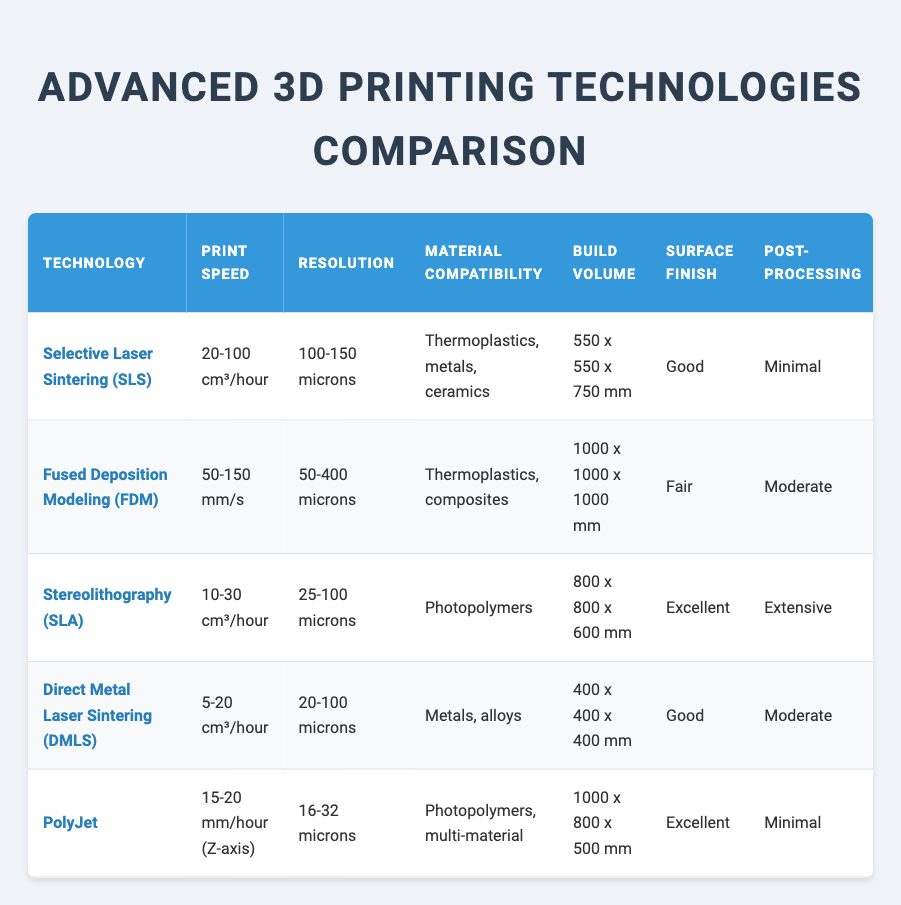What is the print speed range for Stereolithography (SLA)? The print speed for Stereolithography (SLA) is listed as 10-30 cm³/hour in the table.
Answer: 10-30 cm³/hour Which technology has the highest energy efficiency? The highest energy efficiency is indicated for Fused Deposition Modeling (FDM), which is labeled as "High."
Answer: Fused Deposition Modeling (FDM) What is the build volume for PolyJet technology? The build volume for PolyJet technology is specified as 1000 x 800 x 500 mm in the table.
Answer: 1000 x 800 x 500 mm Does Direct Metal Laser Sintering (DMLS) require extensive post-processing? No, Direct Metal Laser Sintering (DMLS) requires moderate post-processing, not extensive, as stated in the table.
Answer: No Which 3D printing technology has the best surface finish? Both Stereolithography (SLA) and PolyJet have an excellent surface finish according to the table. Therefore, they have the best surface finishes among the listed technologies.
Answer: Stereolithography (SLA) and PolyJet If we consider the cost per part, which technology is the least expensive? Fused Deposition Modeling (FDM) is indicated as the least expensive technology with a cost per part of "$," making it the most economical option in the table.
Answer: Fused Deposition Modeling (FDM) What is the difference in print speed between Selective Laser Sintering (SLS) and Fused Deposition Modeling (FDM)? The print speed for SLS is 20-100 cm³/hour and for FDM it is 50-150 mm/s. First, converting FDM's speed to the same units as SLS (1 cm³ is approximately 1000 mm³), means that FDM can range from about 30-450 cm³/hour. Therefore, the difference in maximum print speed is 450 - 100 = 350 cm³/hour, and the minimum is 30 - 20 = 10 cm³/hour.
Answer: Maximum difference: 350 cm³/hour; Minimum difference: 10 cm³/hour Which technology can print the largest build volume? Fused Deposition Modeling (FDM) can print the largest build volume of 1000 x 1000 x 1000 mm, according to the table.
Answer: Fused Deposition Modeling (FDM) Is PolyJet compatible with metals? No, PolyJet is compatible with photopolymers and multi-materials, but not metals as stated in the table.
Answer: No What is the average resolution for all listed technologies? The resolutions are 100-150 microns (SLS), 50-400 microns (FDM), 25-100 microns (SLA), 20-100 microns (DMLS), and 16-32 microns (PolyJet). To find the average, we first convert all resolutions to microns. The resolution ranges converted are: SLS (125), FDM (225), SLA (62.5), DMLS (60), and PolyJet (24). Thus, the average is (125 + 225 + 62.5 + 60 + 24)/5 = 78.5 microns.
Answer: 78.5 microns 